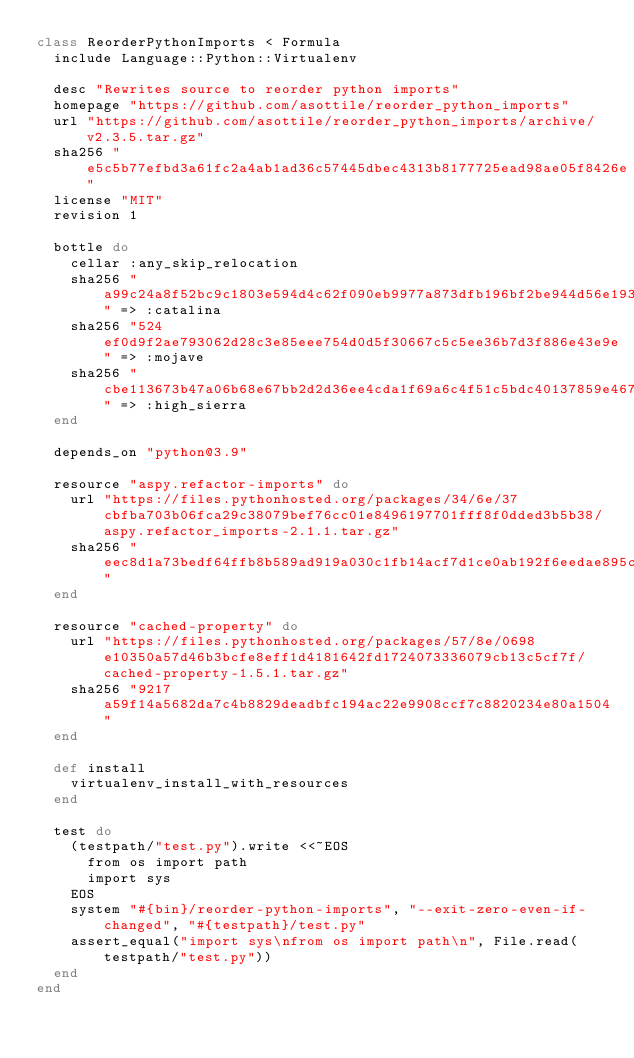<code> <loc_0><loc_0><loc_500><loc_500><_Ruby_>class ReorderPythonImports < Formula
  include Language::Python::Virtualenv

  desc "Rewrites source to reorder python imports"
  homepage "https://github.com/asottile/reorder_python_imports"
  url "https://github.com/asottile/reorder_python_imports/archive/v2.3.5.tar.gz"
  sha256 "e5c5b77efbd3a61fc2a4ab1ad36c57445dbec4313b8177725ead98ae05f8426e"
  license "MIT"
  revision 1

  bottle do
    cellar :any_skip_relocation
    sha256 "a99c24a8f52bc9c1803e594d4c62f090eb9977a873dfb196bf2be944d56e193d" => :catalina
    sha256 "524ef0d9f2ae793062d28c3e85eee754d0d5f30667c5c5ee36b7d3f886e43e9e" => :mojave
    sha256 "cbe113673b47a06b68e67bb2d2d36ee4cda1f69a6c4f51c5bdc40137859e4675" => :high_sierra
  end

  depends_on "python@3.9"

  resource "aspy.refactor-imports" do
    url "https://files.pythonhosted.org/packages/34/6e/37cbfba703b06fca29c38079bef76cc01e8496197701fff8f0dded3b5b38/aspy.refactor_imports-2.1.1.tar.gz"
    sha256 "eec8d1a73bedf64ffb8b589ad919a030c1fb14acf7d1ce0ab192f6eedae895c5"
  end

  resource "cached-property" do
    url "https://files.pythonhosted.org/packages/57/8e/0698e10350a57d46b3bcfe8eff1d4181642fd1724073336079cb13c5cf7f/cached-property-1.5.1.tar.gz"
    sha256 "9217a59f14a5682da7c4b8829deadbfc194ac22e9908ccf7c8820234e80a1504"
  end

  def install
    virtualenv_install_with_resources
  end

  test do
    (testpath/"test.py").write <<~EOS
      from os import path
      import sys
    EOS
    system "#{bin}/reorder-python-imports", "--exit-zero-even-if-changed", "#{testpath}/test.py"
    assert_equal("import sys\nfrom os import path\n", File.read(testpath/"test.py"))
  end
end
</code> 